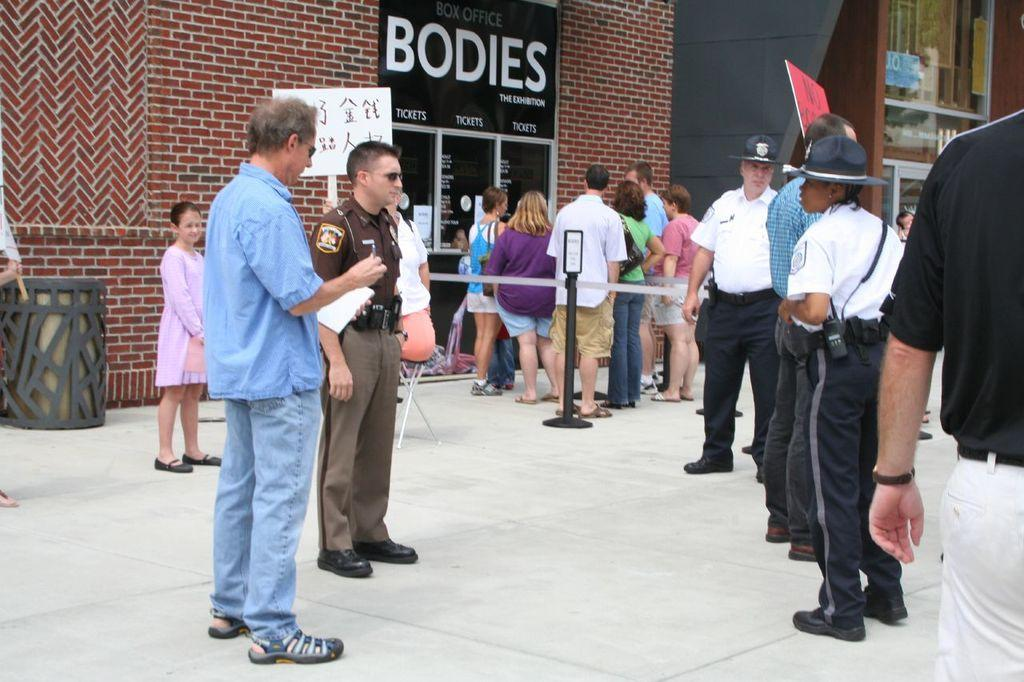What can be seen in the image involving people? There are people standing in the image. What objects are present in the image that might be used for crowd control or traffic management? There are barrier poles in the image. What type of receptacles are visible in the image? There are bins in the image. What type of structures can be seen in the background of the image? There are walls in the image. What type of signage is present in the image? There is an advertisement board in the image. What type of food is being served by the men in the image? There are no men or food present in the image. Can you describe the beetle that is crawling on the advertisement board? There is no beetle present on the advertisement board or anywhere else in the image. 